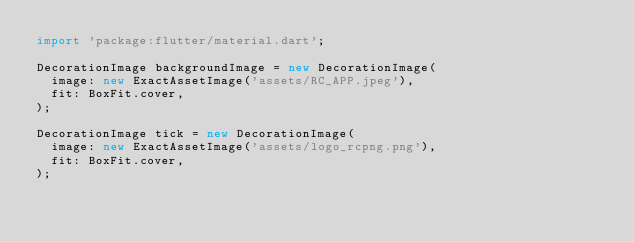<code> <loc_0><loc_0><loc_500><loc_500><_Dart_>import 'package:flutter/material.dart';

DecorationImage backgroundImage = new DecorationImage(
  image: new ExactAssetImage('assets/RC_APP.jpeg'),
  fit: BoxFit.cover,
);

DecorationImage tick = new DecorationImage(
  image: new ExactAssetImage('assets/logo_rcpng.png'),
  fit: BoxFit.cover,
);
</code> 